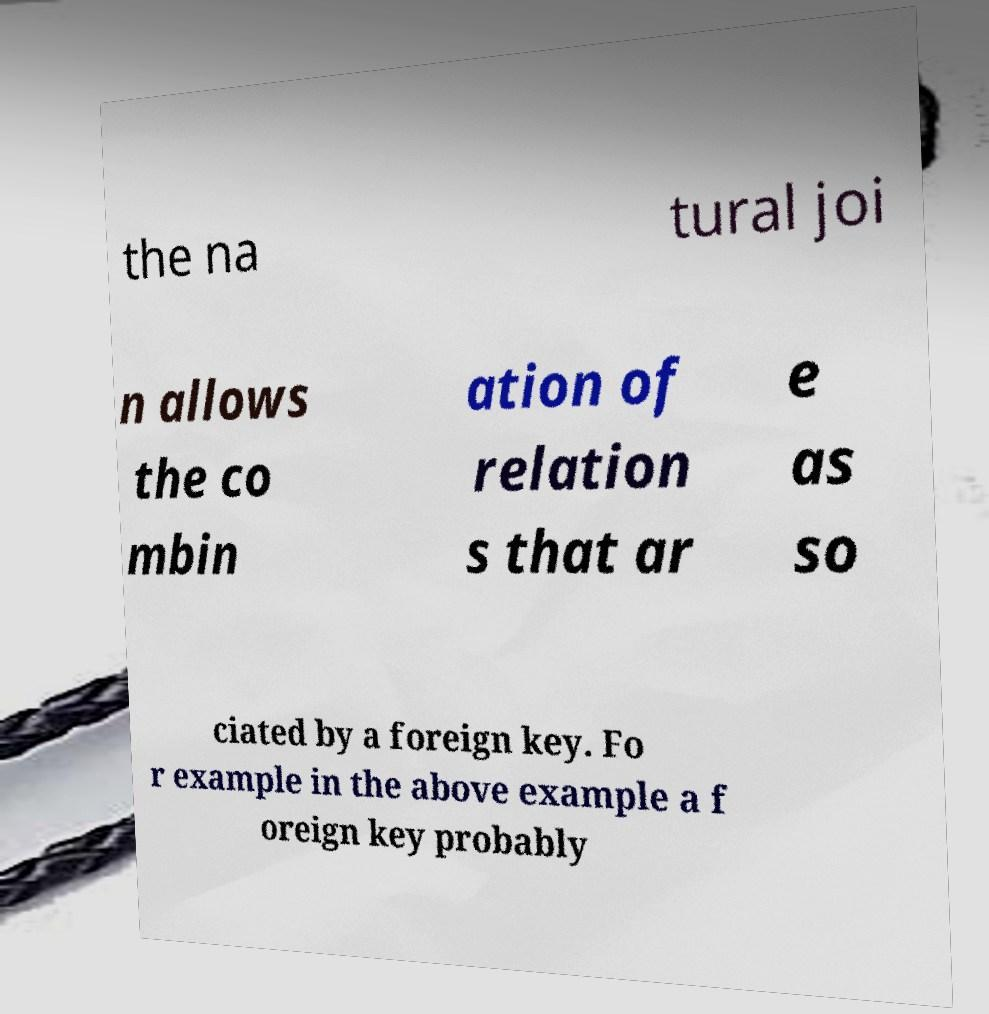For documentation purposes, I need the text within this image transcribed. Could you provide that? the na tural joi n allows the co mbin ation of relation s that ar e as so ciated by a foreign key. Fo r example in the above example a f oreign key probably 